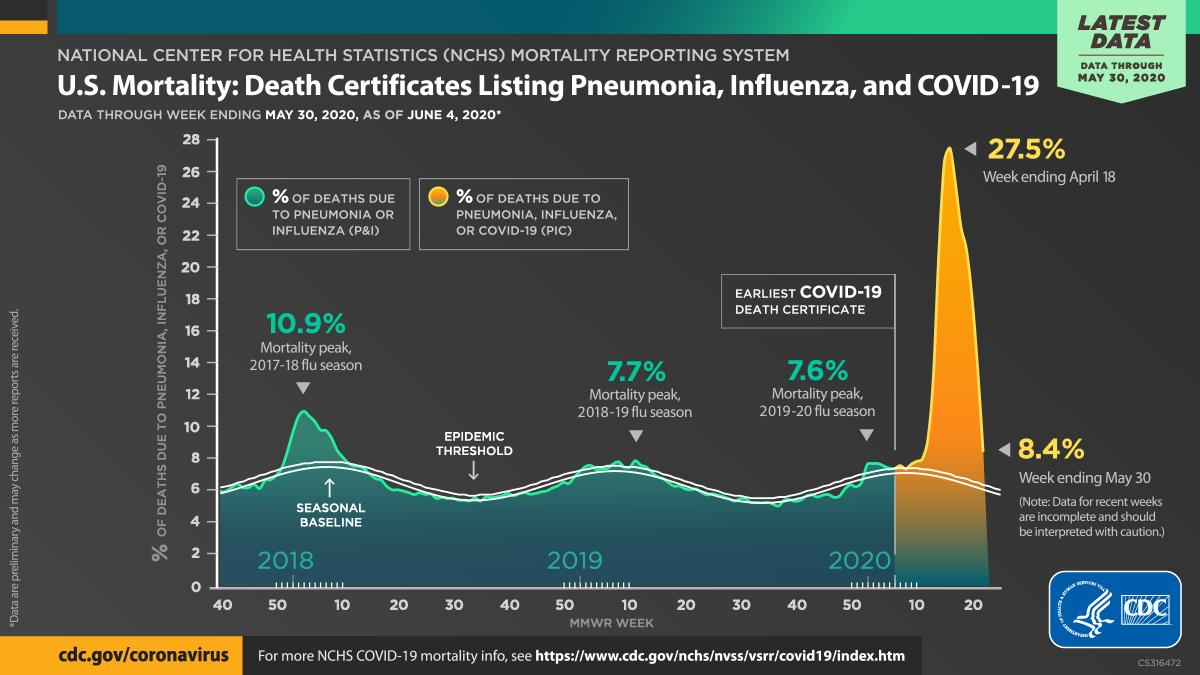Mention a couple of crucial points in this snapshot. The highest number of COVID-19 related deaths occurred in April. The COVID-19 deaths were first recorded in 2020. According to data collected in 2019, the highest mortality peak due to pneumonia or influenza was 7.7%. According to data from 2018, the highest mortality peak due to pneumonia or influenza was 10.9%. 